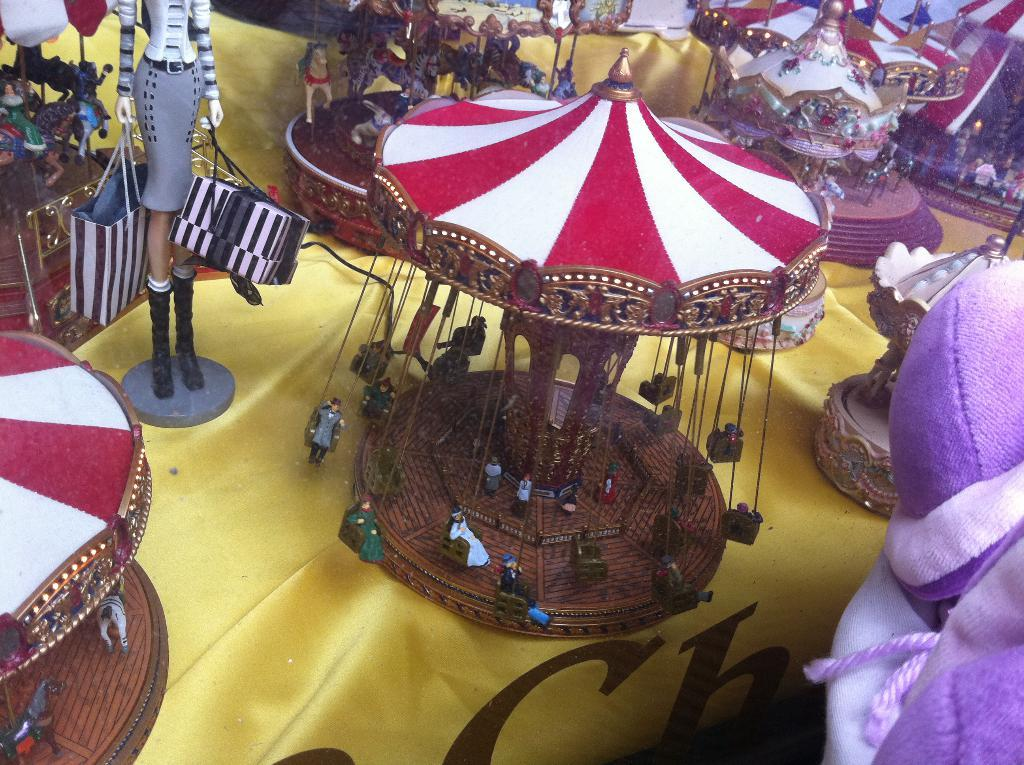What type of objects can be seen in the image? There are toys, carousels, bags, and clothes in the image. Can you describe the carousels in the image? The carousels in the image are likely small, toy-like versions of the larger amusement park rides. What might the bags be used for? The bags in the image could be used for carrying or storing items, such as the toys or clothes. What other unspecified objects are present in the image? There are other unspecified objects in the image, but we cannot determine their exact nature from the provided facts. What type of reaction can be seen in the image? There is no reaction visible in the image, as it is a still image and does not depict any actions or emotions. 